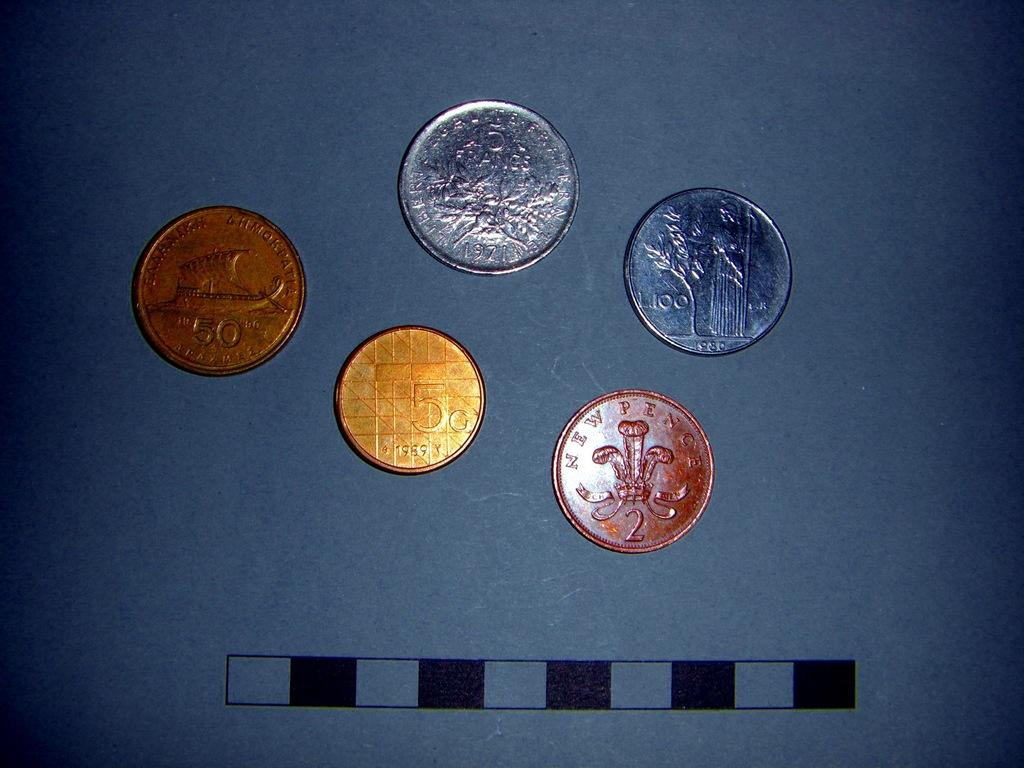<image>
Write a terse but informative summary of the picture. Five various colored coins including one from new pence. 